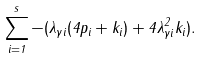<formula> <loc_0><loc_0><loc_500><loc_500>\sum _ { i = 1 } ^ { s } - ( \lambda _ { \gamma i } ( 4 p _ { i } + k _ { i } ) + 4 \lambda _ { \gamma i } ^ { 2 } k _ { i } ) .</formula> 